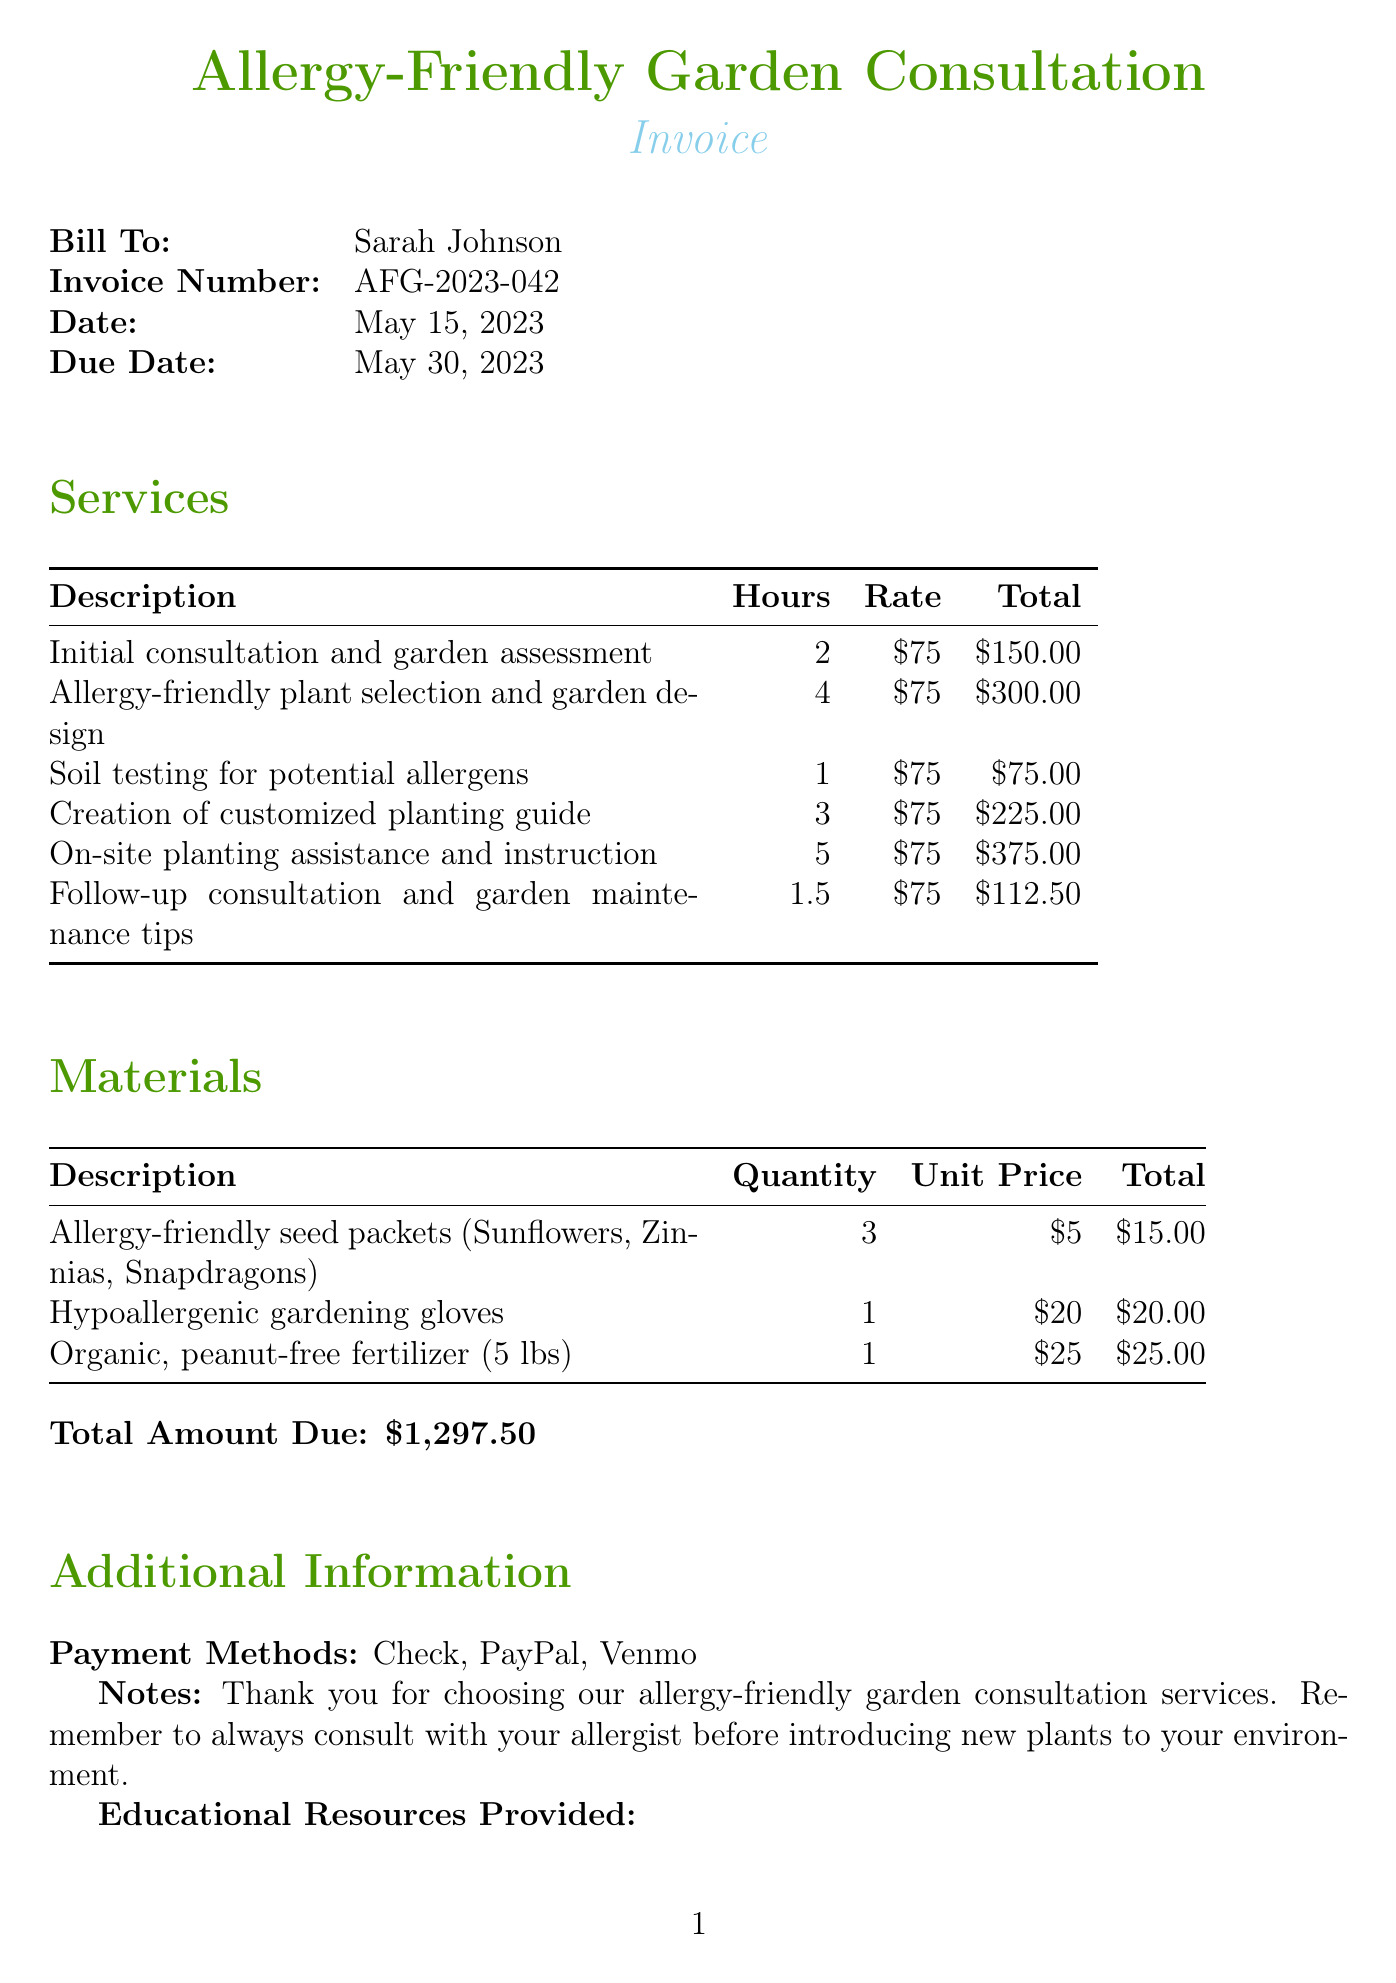What is the invoice number? The invoice number is listed prominently at the beginning of the document.
Answer: AFG-2023-042 Who is the client? The document indicates the name of the client at the top of the invoice.
Answer: Sarah Johnson What is the total amount due? The total amount due is mentioned at the end of the document in a dedicated section.
Answer: $1,297.50 How many hours were spent on soil testing? The hours for each service are detailed in the services section of the invoice.
Answer: 1 What materials were provided? The materials section lists items that were supplied during the consultation.
Answer: Allergy-friendly seed packets, Hypoallergenic gardening gloves, Organic peanut-free fertilizer How many educational resources were provided? The additional information section includes a list of educational resources.
Answer: 3 What is the rate per hour for services? The rate is consistent for all services and can be found in the services table.
Answer: $75 When is the due date for the invoice? The due date is explicitly stated near the client's details on the invoice.
Answer: May 30, 2023 What type of payment methods are accepted? The document specifies the accepted payment methods in the additional information section.
Answer: Check, PayPal, Venmo 